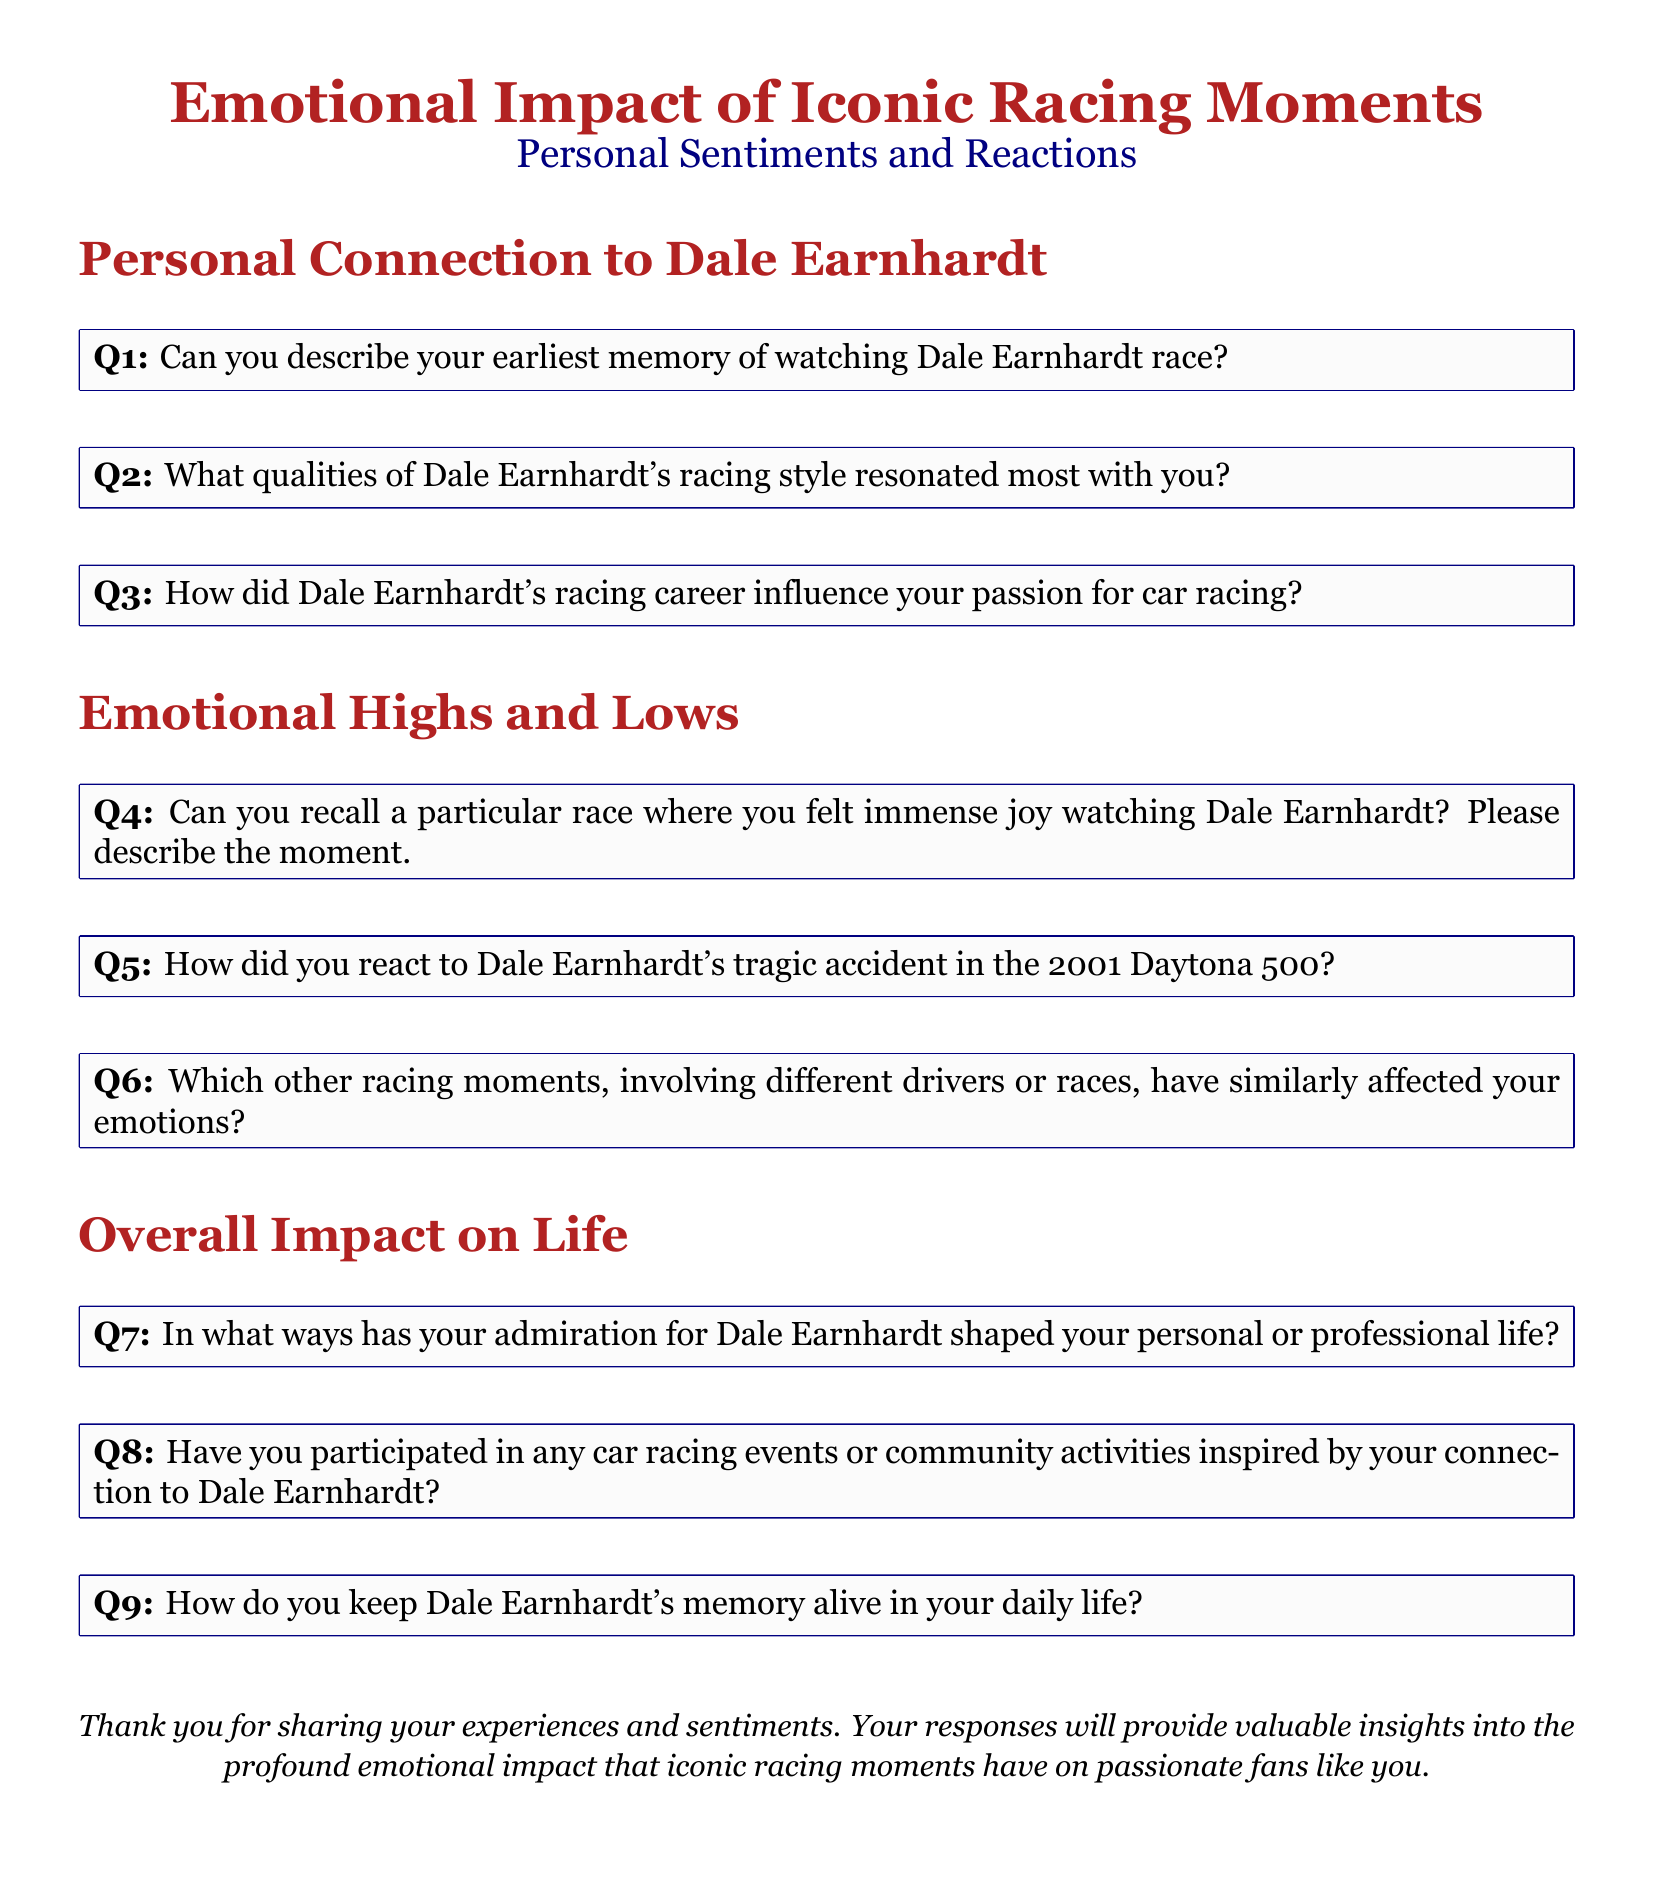What is the title of the document? The title of the document is stated at the top and includes the main subject of the questionnaire.
Answer: Emotional Impact of Iconic Racing Moments How many main sections are there in the document? The document has three main sections as indicated by the headings.
Answer: 3 What is the color of the box used for questions? The color of the box is described in the document using a specific color definition.
Answer: racinggray Which year did Dale Earnhardt's tragic accident occur? The tragic accident year can be inferred from the context of the question about the 2001 Daytona 500 race.
Answer: 2001 What type of sentiments does the document focus on? The document is focused on personal sentiments and reactions related to racing.
Answer: Emotional Which section contains questions about personal connection to Dale Earnhardt? The section is explicitly titled similar to the questions asked within it.
Answer: Personal Connection to Dale Earnhardt How many questions are there in the Emotional Highs and Lows section? The number of questions can be counted in the specific section focused on highs and lows of emotions.
Answer: 3 What is the final statement urging participants to do? The last statement indicates a request for participants' contributions to the questionnaire's goal.
Answer: Sharing experiences and sentiments What is the color of the main text in the title section? The color is explicitly specified for the title of the document in the formatting section.
Answer: racingred 